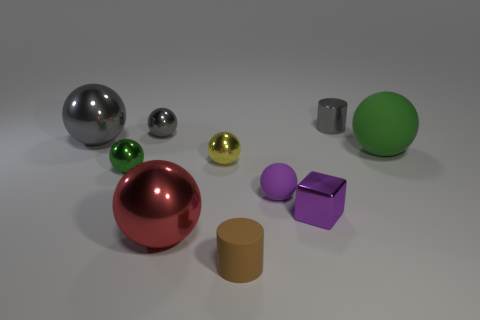Subtract 2 balls. How many balls are left? 5 Subtract all purple balls. How many balls are left? 6 Subtract all green balls. How many balls are left? 5 Subtract all purple spheres. Subtract all red blocks. How many spheres are left? 6 Subtract all balls. How many objects are left? 3 Subtract 0 yellow cylinders. How many objects are left? 10 Subtract all blocks. Subtract all tiny purple rubber objects. How many objects are left? 8 Add 6 green rubber objects. How many green rubber objects are left? 7 Add 6 tiny green metallic things. How many tiny green metallic things exist? 7 